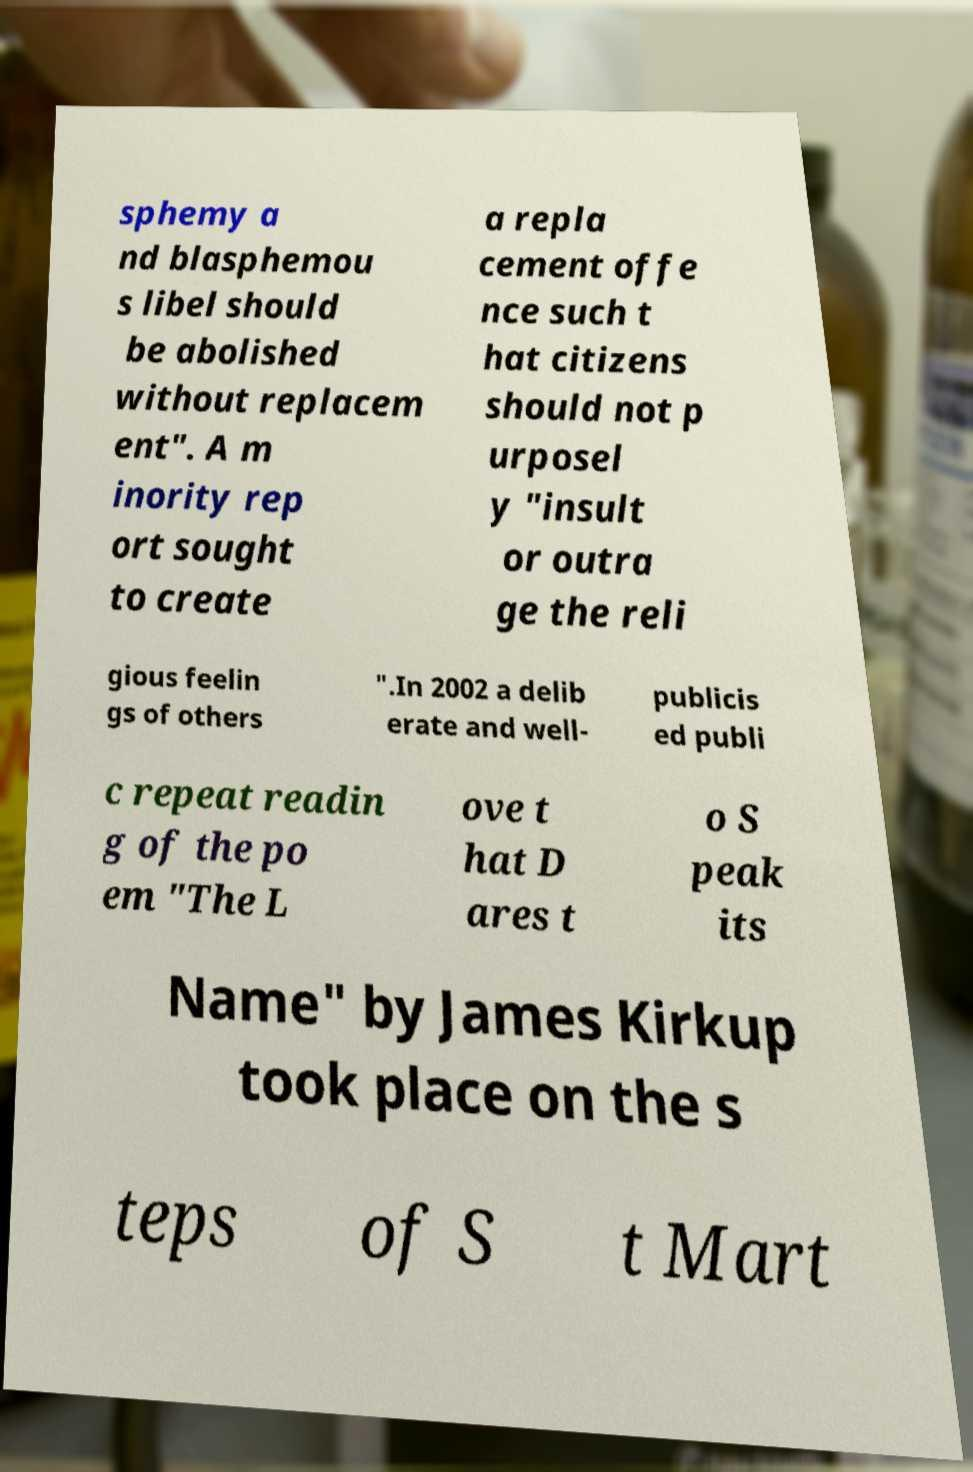Can you read and provide the text displayed in the image?This photo seems to have some interesting text. Can you extract and type it out for me? sphemy a nd blasphemou s libel should be abolished without replacem ent". A m inority rep ort sought to create a repla cement offe nce such t hat citizens should not p urposel y "insult or outra ge the reli gious feelin gs of others ".In 2002 a delib erate and well- publicis ed publi c repeat readin g of the po em "The L ove t hat D ares t o S peak its Name" by James Kirkup took place on the s teps of S t Mart 